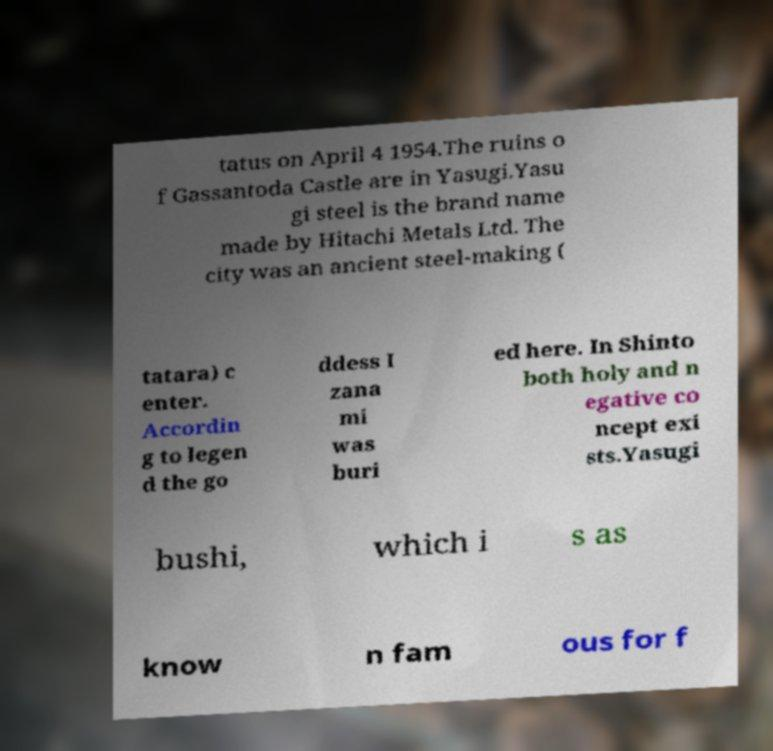Can you accurately transcribe the text from the provided image for me? tatus on April 4 1954.The ruins o f Gassantoda Castle are in Yasugi.Yasu gi steel is the brand name made by Hitachi Metals Ltd. The city was an ancient steel-making ( tatara) c enter. Accordin g to legen d the go ddess I zana mi was buri ed here. In Shinto both holy and n egative co ncept exi sts.Yasugi bushi, which i s as know n fam ous for f 